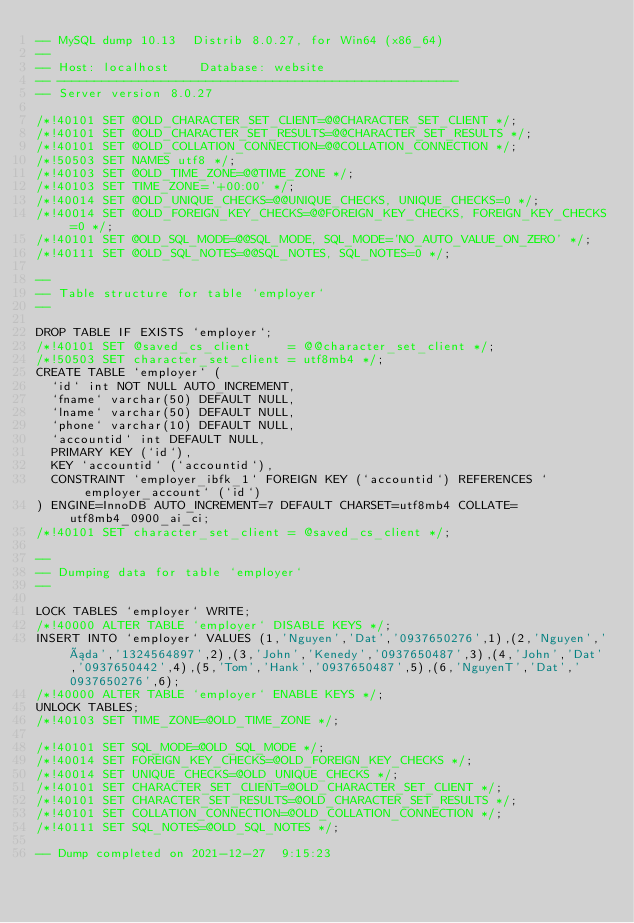<code> <loc_0><loc_0><loc_500><loc_500><_SQL_>-- MySQL dump 10.13  Distrib 8.0.27, for Win64 (x86_64)
--
-- Host: localhost    Database: website
-- ------------------------------------------------------
-- Server version	8.0.27

/*!40101 SET @OLD_CHARACTER_SET_CLIENT=@@CHARACTER_SET_CLIENT */;
/*!40101 SET @OLD_CHARACTER_SET_RESULTS=@@CHARACTER_SET_RESULTS */;
/*!40101 SET @OLD_COLLATION_CONNECTION=@@COLLATION_CONNECTION */;
/*!50503 SET NAMES utf8 */;
/*!40103 SET @OLD_TIME_ZONE=@@TIME_ZONE */;
/*!40103 SET TIME_ZONE='+00:00' */;
/*!40014 SET @OLD_UNIQUE_CHECKS=@@UNIQUE_CHECKS, UNIQUE_CHECKS=0 */;
/*!40014 SET @OLD_FOREIGN_KEY_CHECKS=@@FOREIGN_KEY_CHECKS, FOREIGN_KEY_CHECKS=0 */;
/*!40101 SET @OLD_SQL_MODE=@@SQL_MODE, SQL_MODE='NO_AUTO_VALUE_ON_ZERO' */;
/*!40111 SET @OLD_SQL_NOTES=@@SQL_NOTES, SQL_NOTES=0 */;

--
-- Table structure for table `employer`
--

DROP TABLE IF EXISTS `employer`;
/*!40101 SET @saved_cs_client     = @@character_set_client */;
/*!50503 SET character_set_client = utf8mb4 */;
CREATE TABLE `employer` (
  `id` int NOT NULL AUTO_INCREMENT,
  `fname` varchar(50) DEFAULT NULL,
  `lname` varchar(50) DEFAULT NULL,
  `phone` varchar(10) DEFAULT NULL,
  `accountid` int DEFAULT NULL,
  PRIMARY KEY (`id`),
  KEY `accountid` (`accountid`),
  CONSTRAINT `employer_ibfk_1` FOREIGN KEY (`accountid`) REFERENCES `employer_account` (`id`)
) ENGINE=InnoDB AUTO_INCREMENT=7 DEFAULT CHARSET=utf8mb4 COLLATE=utf8mb4_0900_ai_ci;
/*!40101 SET character_set_client = @saved_cs_client */;

--
-- Dumping data for table `employer`
--

LOCK TABLES `employer` WRITE;
/*!40000 ALTER TABLE `employer` DISABLE KEYS */;
INSERT INTO `employer` VALUES (1,'Nguyen','Dat','0937650276',1),(2,'Nguyen','áda','1324564897',2),(3,'John','Kenedy','0937650487',3),(4,'John','Dat','0937650442',4),(5,'Tom','Hank','0937650487',5),(6,'NguyenT','Dat','0937650276',6);
/*!40000 ALTER TABLE `employer` ENABLE KEYS */;
UNLOCK TABLES;
/*!40103 SET TIME_ZONE=@OLD_TIME_ZONE */;

/*!40101 SET SQL_MODE=@OLD_SQL_MODE */;
/*!40014 SET FOREIGN_KEY_CHECKS=@OLD_FOREIGN_KEY_CHECKS */;
/*!40014 SET UNIQUE_CHECKS=@OLD_UNIQUE_CHECKS */;
/*!40101 SET CHARACTER_SET_CLIENT=@OLD_CHARACTER_SET_CLIENT */;
/*!40101 SET CHARACTER_SET_RESULTS=@OLD_CHARACTER_SET_RESULTS */;
/*!40101 SET COLLATION_CONNECTION=@OLD_COLLATION_CONNECTION */;
/*!40111 SET SQL_NOTES=@OLD_SQL_NOTES */;

-- Dump completed on 2021-12-27  9:15:23
</code> 